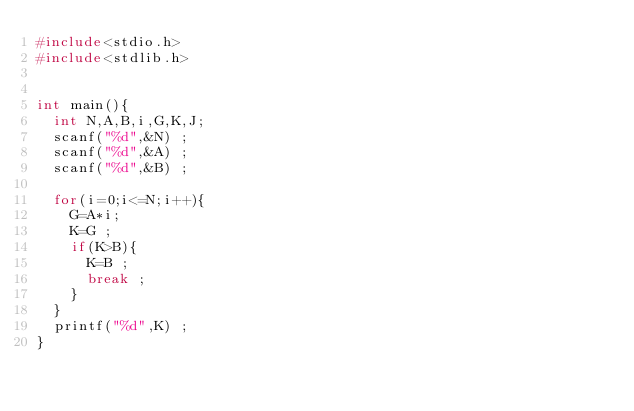Convert code to text. <code><loc_0><loc_0><loc_500><loc_500><_C_>#include<stdio.h>
#include<stdlib.h>


int main(){
  int N,A,B,i,G,K,J;
  scanf("%d",&N) ;
  scanf("%d",&A) ;
  scanf("%d",&B) ;

  for(i=0;i<=N;i++){
    G=A*i;
    K=G ;
    if(K>B){
      K=B ;
      break ;
    }
  }
  printf("%d",K) ;
}
</code> 